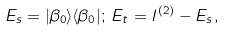Convert formula to latex. <formula><loc_0><loc_0><loc_500><loc_500>E _ { s } = | \beta _ { 0 } \rangle \langle \beta _ { 0 } | ; \, E _ { t } = I ^ { ( 2 ) } - E _ { s } ,</formula> 